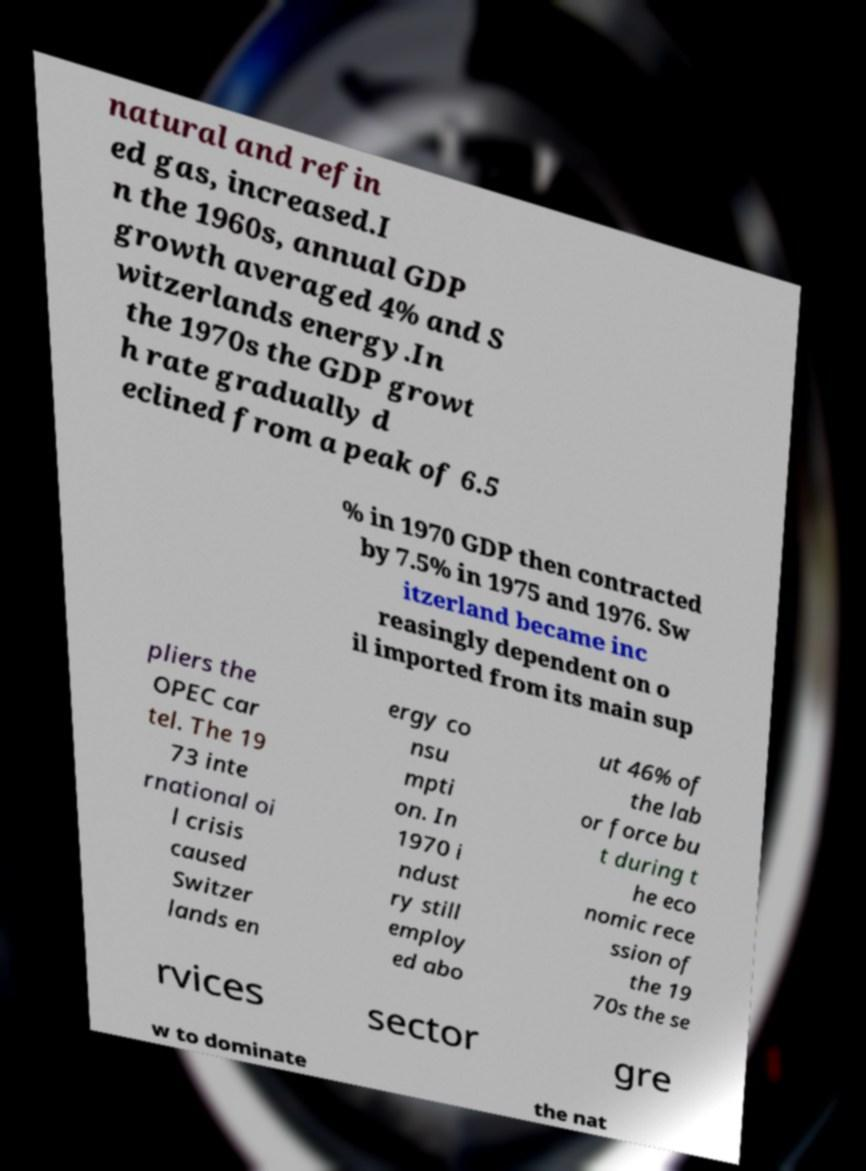What messages or text are displayed in this image? I need them in a readable, typed format. natural and refin ed gas, increased.I n the 1960s, annual GDP growth averaged 4% and S witzerlands energy.In the 1970s the GDP growt h rate gradually d eclined from a peak of 6.5 % in 1970 GDP then contracted by 7.5% in 1975 and 1976. Sw itzerland became inc reasingly dependent on o il imported from its main sup pliers the OPEC car tel. The 19 73 inte rnational oi l crisis caused Switzer lands en ergy co nsu mpti on. In 1970 i ndust ry still employ ed abo ut 46% of the lab or force bu t during t he eco nomic rece ssion of the 19 70s the se rvices sector gre w to dominate the nat 